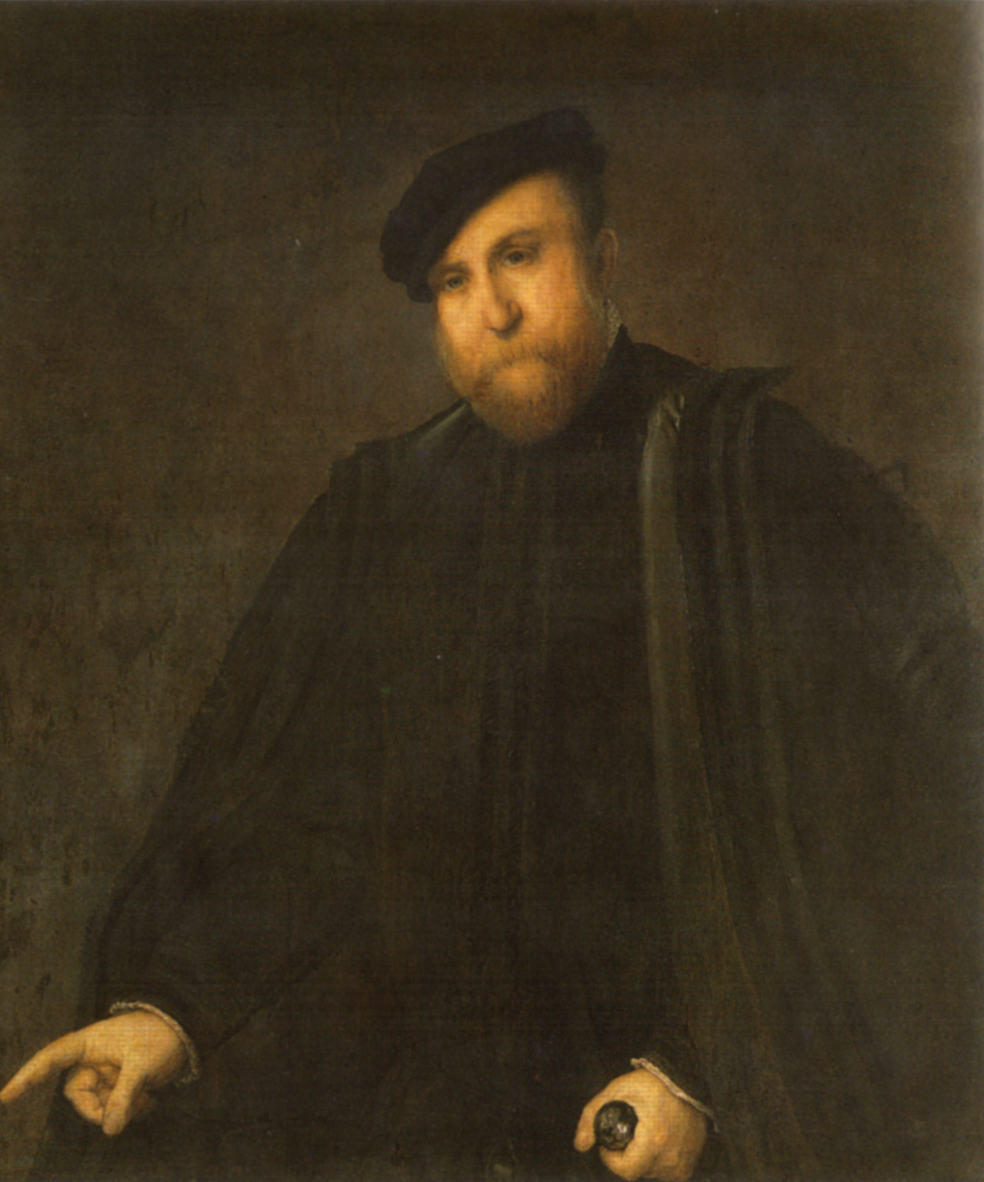What can the choice of clothing and accessories tell us about the person in this image? The man's attire, consisting of a richly tailored dark cloak and a formal hat, along with accessories like gloves and a cane, strongly suggests that he was a figure of significant social stature and wealth during his time. Such clothing was typically worn by the nobility or upper echelons of society in European history, indicating his high social rank. The dark palette and substantial fabrics also point to a preference for conveying seriousness and dignity, crucial traits in formal portraits meant to immortalize an individual’s legacy. 